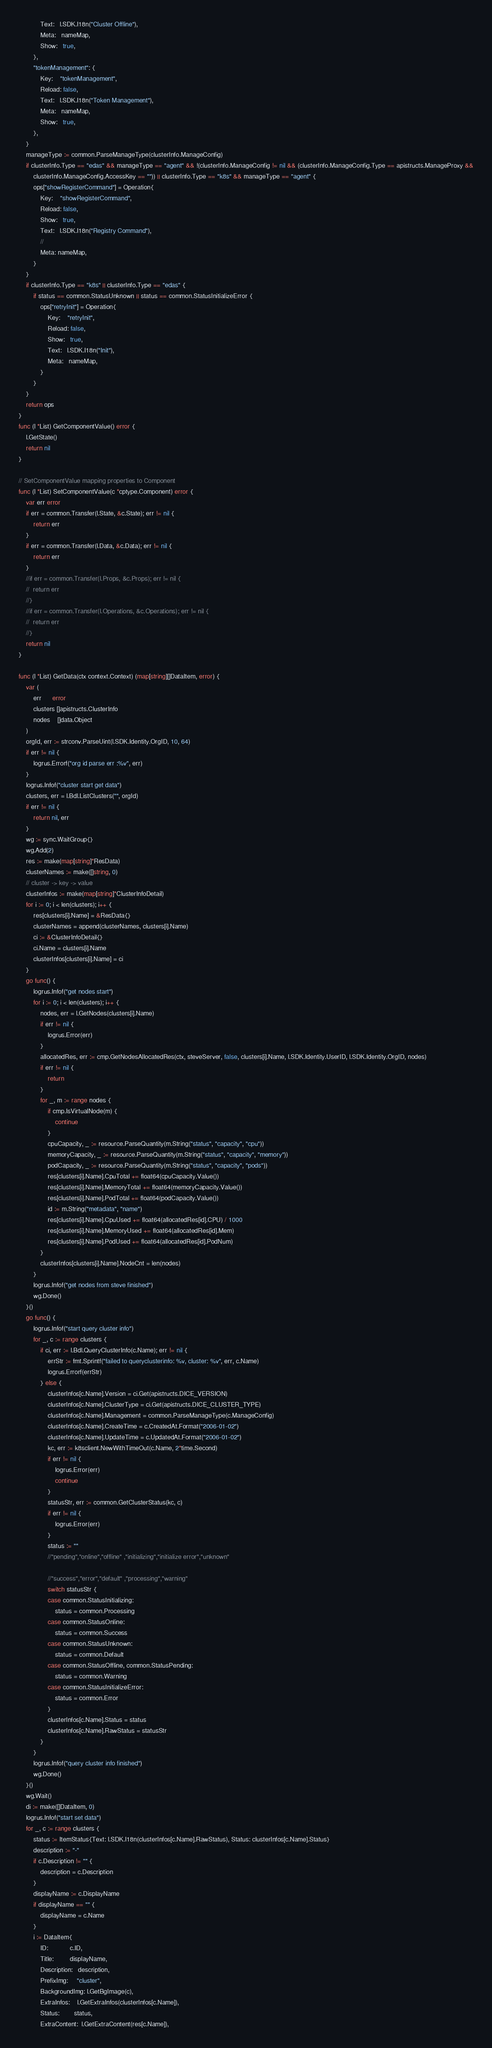Convert code to text. <code><loc_0><loc_0><loc_500><loc_500><_Go_>			Text:   l.SDK.I18n("Cluster Offline"),
			Meta:   nameMap,
			Show:   true,
		},
		"tokenManagement": {
			Key:    "tokenManagement",
			Reload: false,
			Text:   l.SDK.I18n("Token Management"),
			Meta:   nameMap,
			Show:   true,
		},
	}
	manageType := common.ParseManageType(clusterInfo.ManageConfig)
	if clusterInfo.Type == "edas" && manageType == "agent" && !(clusterInfo.ManageConfig != nil && (clusterInfo.ManageConfig.Type == apistructs.ManageProxy &&
		clusterInfo.ManageConfig.AccessKey == "")) || clusterInfo.Type == "k8s" && manageType == "agent" {
		ops["showRegisterCommand"] = Operation{
			Key:    "showRegisterCommand",
			Reload: false,
			Show:   true,
			Text:   l.SDK.I18n("Registry Command"),
			//
			Meta: nameMap,
		}
	}
	if clusterInfo.Type == "k8s" || clusterInfo.Type == "edas" {
		if status == common.StatusUnknown || status == common.StatusInitializeError {
			ops["retryInit"] = Operation{
				Key:    "retryInit",
				Reload: false,
				Show:   true,
				Text:   l.SDK.I18n("Init"),
				Meta:   nameMap,
			}
		}
	}
	return ops
}
func (l *List) GetComponentValue() error {
	l.GetState()
	return nil
}

// SetComponentValue mapping properties to Component
func (l *List) SetComponentValue(c *cptype.Component) error {
	var err error
	if err = common.Transfer(l.State, &c.State); err != nil {
		return err
	}
	if err = common.Transfer(l.Data, &c.Data); err != nil {
		return err
	}
	//if err = common.Transfer(l.Props, &c.Props); err != nil {
	//	return err
	//}
	//if err = common.Transfer(l.Operations, &c.Operations); err != nil {
	//	return err
	//}
	return nil
}

func (l *List) GetData(ctx context.Context) (map[string][]DataItem, error) {
	var (
		err      error
		clusters []apistructs.ClusterInfo
		nodes    []data.Object
	)
	orgId, err := strconv.ParseUint(l.SDK.Identity.OrgID, 10, 64)
	if err != nil {
		logrus.Errorf("org id parse err :%v", err)
	}
	logrus.Infof("cluster start get data")
	clusters, err = l.Bdl.ListClusters("", orgId)
	if err != nil {
		return nil, err
	}
	wg := sync.WaitGroup{}
	wg.Add(2)
	res := make(map[string]*ResData)
	clusterNames := make([]string, 0)
	// cluster -> key -> value
	clusterInfos := make(map[string]*ClusterInfoDetail)
	for i := 0; i < len(clusters); i++ {
		res[clusters[i].Name] = &ResData{}
		clusterNames = append(clusterNames, clusters[i].Name)
		ci := &ClusterInfoDetail{}
		ci.Name = clusters[i].Name
		clusterInfos[clusters[i].Name] = ci
	}
	go func() {
		logrus.Infof("get nodes start")
		for i := 0; i < len(clusters); i++ {
			nodes, err = l.GetNodes(clusters[i].Name)
			if err != nil {
				logrus.Error(err)
			}
			allocatedRes, err := cmp.GetNodesAllocatedRes(ctx, steveServer, false, clusters[i].Name, l.SDK.Identity.UserID, l.SDK.Identity.OrgID, nodes)
			if err != nil {
				return
			}
			for _, m := range nodes {
				if cmp.IsVirtualNode(m) {
					continue
				}
				cpuCapacity, _ := resource.ParseQuantity(m.String("status", "capacity", "cpu"))
				memoryCapacity, _ := resource.ParseQuantity(m.String("status", "capacity", "memory"))
				podCapacity, _ := resource.ParseQuantity(m.String("status", "capacity", "pods"))
				res[clusters[i].Name].CpuTotal += float64(cpuCapacity.Value())
				res[clusters[i].Name].MemoryTotal += float64(memoryCapacity.Value())
				res[clusters[i].Name].PodTotal += float64(podCapacity.Value())
				id := m.String("metadata", "name")
				res[clusters[i].Name].CpuUsed += float64(allocatedRes[id].CPU) / 1000
				res[clusters[i].Name].MemoryUsed += float64(allocatedRes[id].Mem)
				res[clusters[i].Name].PodUsed += float64(allocatedRes[id].PodNum)
			}
			clusterInfos[clusters[i].Name].NodeCnt = len(nodes)
		}
		logrus.Infof("get nodes from steve finished")
		wg.Done()
	}()
	go func() {
		logrus.Infof("start query cluster info")
		for _, c := range clusters {
			if ci, err := l.Bdl.QueryClusterInfo(c.Name); err != nil {
				errStr := fmt.Sprintf("failed to queryclusterinfo: %v, cluster: %v", err, c.Name)
				logrus.Errorf(errStr)
			} else {
				clusterInfos[c.Name].Version = ci.Get(apistructs.DICE_VERSION)
				clusterInfos[c.Name].ClusterType = ci.Get(apistructs.DICE_CLUSTER_TYPE)
				clusterInfos[c.Name].Management = common.ParseManageType(c.ManageConfig)
				clusterInfos[c.Name].CreateTime = c.CreatedAt.Format("2006-01-02")
				clusterInfos[c.Name].UpdateTime = c.UpdatedAt.Format("2006-01-02")
				kc, err := k8sclient.NewWithTimeOut(c.Name, 2*time.Second)
				if err != nil {
					logrus.Error(err)
					continue
				}
				statusStr, err := common.GetClusterStatus(kc, c)
				if err != nil {
					logrus.Error(err)
				}
				status := ""
				//"pending","online","offline" ,"initializing","initialize error","unknown"

				//"success","error","default" ,"processing","warning"
				switch statusStr {
				case common.StatusInitializing:
					status = common.Processing
				case common.StatusOnline:
					status = common.Success
				case common.StatusUnknown:
					status = common.Default
				case common.StatusOffline, common.StatusPending:
					status = common.Warning
				case common.StatusInitializeError:
					status = common.Error
				}
				clusterInfos[c.Name].Status = status
				clusterInfos[c.Name].RawStatus = statusStr
			}
		}
		logrus.Infof("query cluster info finished")
		wg.Done()
	}()
	wg.Wait()
	di := make([]DataItem, 0)
	logrus.Infof("start set data")
	for _, c := range clusters {
		status := ItemStatus{Text: l.SDK.I18n(clusterInfos[c.Name].RawStatus), Status: clusterInfos[c.Name].Status}
		description := "-"
		if c.Description != "" {
			description = c.Description
		}
		displayName := c.DisplayName
		if displayName == "" {
			displayName = c.Name
		}
		i := DataItem{
			ID:            c.ID,
			Title:         displayName,
			Description:   description,
			PrefixImg:     "cluster",
			BackgroundImg: l.GetBgImage(c),
			ExtraInfos:    l.GetExtraInfos(clusterInfos[c.Name]),
			Status:        status,
			ExtraContent:  l.GetExtraContent(res[c.Name]),</code> 